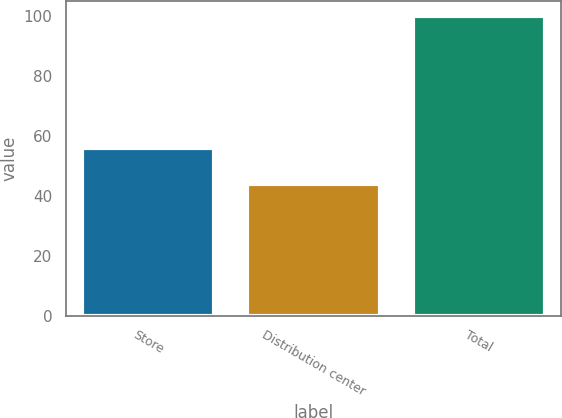Convert chart to OTSL. <chart><loc_0><loc_0><loc_500><loc_500><bar_chart><fcel>Store<fcel>Distribution center<fcel>Total<nl><fcel>56<fcel>44<fcel>100<nl></chart> 